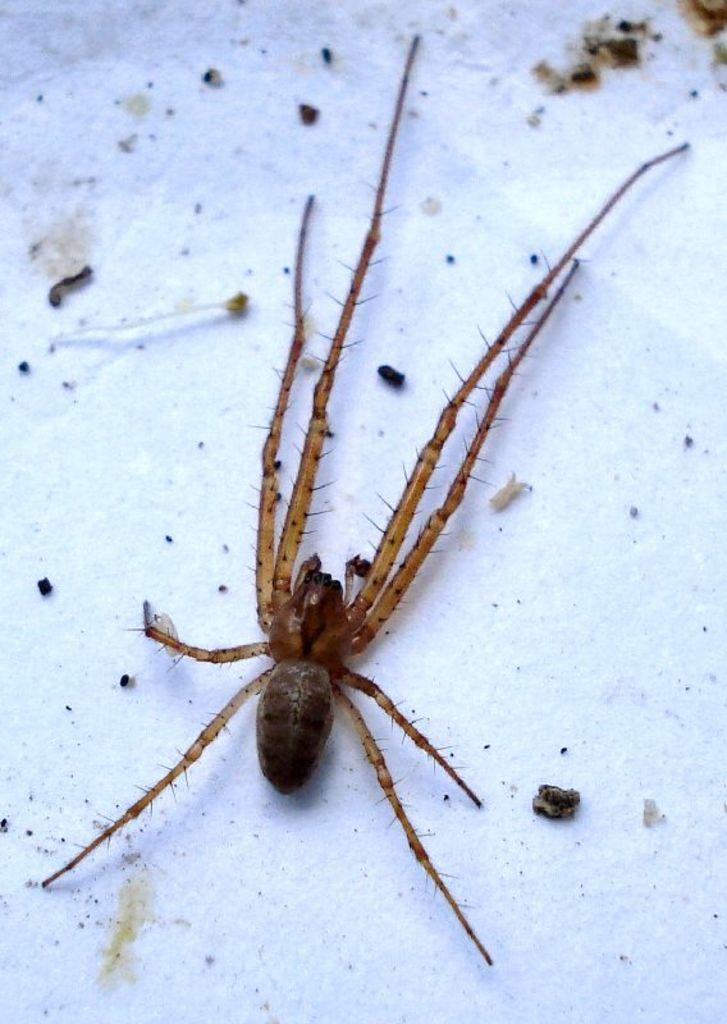What is the main subject of the image? There is a spider in the image. Where is the spider located in the image? The spider is in the center of the image. What surface is the spider on? The spider is on the wall. What thoughts does the spider have about the playground in the image? There is no playground present in the image, and therefore no thoughts about a playground can be attributed to the spider. 